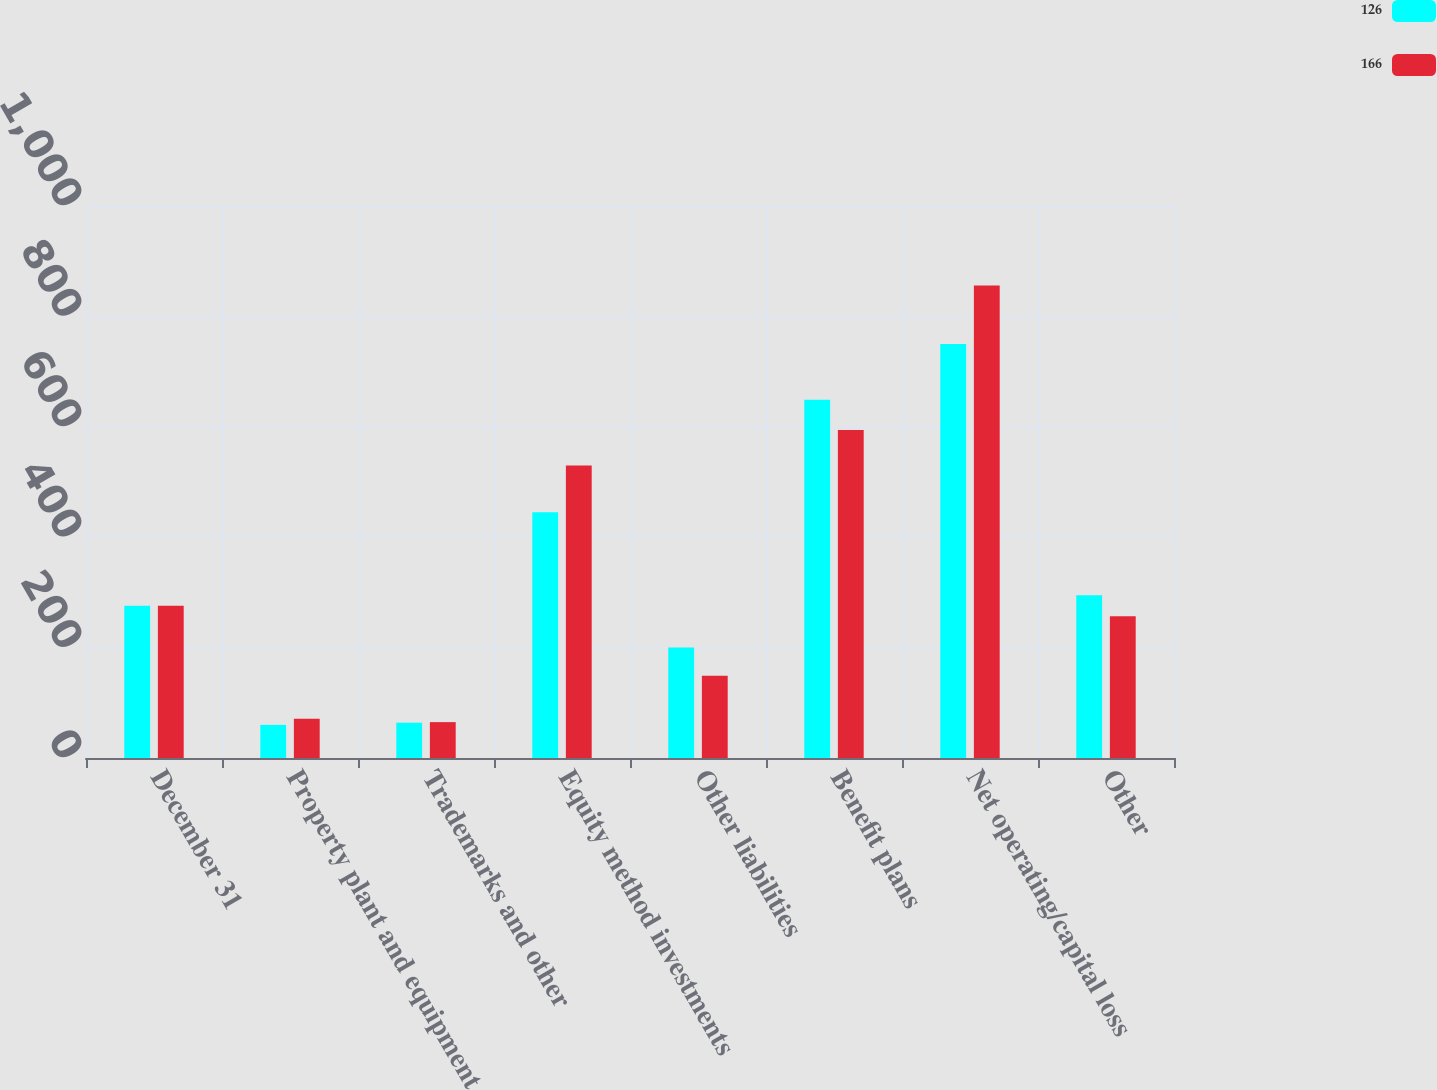Convert chart to OTSL. <chart><loc_0><loc_0><loc_500><loc_500><stacked_bar_chart><ecel><fcel>December 31<fcel>Property plant and equipment<fcel>Trademarks and other<fcel>Equity method investments<fcel>Other liabilities<fcel>Benefit plans<fcel>Net operating/capital loss<fcel>Other<nl><fcel>126<fcel>276<fcel>60<fcel>64<fcel>445<fcel>200<fcel>649<fcel>750<fcel>295<nl><fcel>166<fcel>276<fcel>71<fcel>65<fcel>530<fcel>149<fcel>594<fcel>856<fcel>257<nl></chart> 